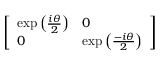Convert formula to latex. <formula><loc_0><loc_0><loc_500><loc_500>\left [ \begin{array} { l l } { \exp \left ( { \frac { i \theta } { 2 } } \right ) } & { 0 } \\ { 0 } & { \exp \left ( { \frac { - i \theta } { 2 } } \right ) } \end{array} \right ]</formula> 